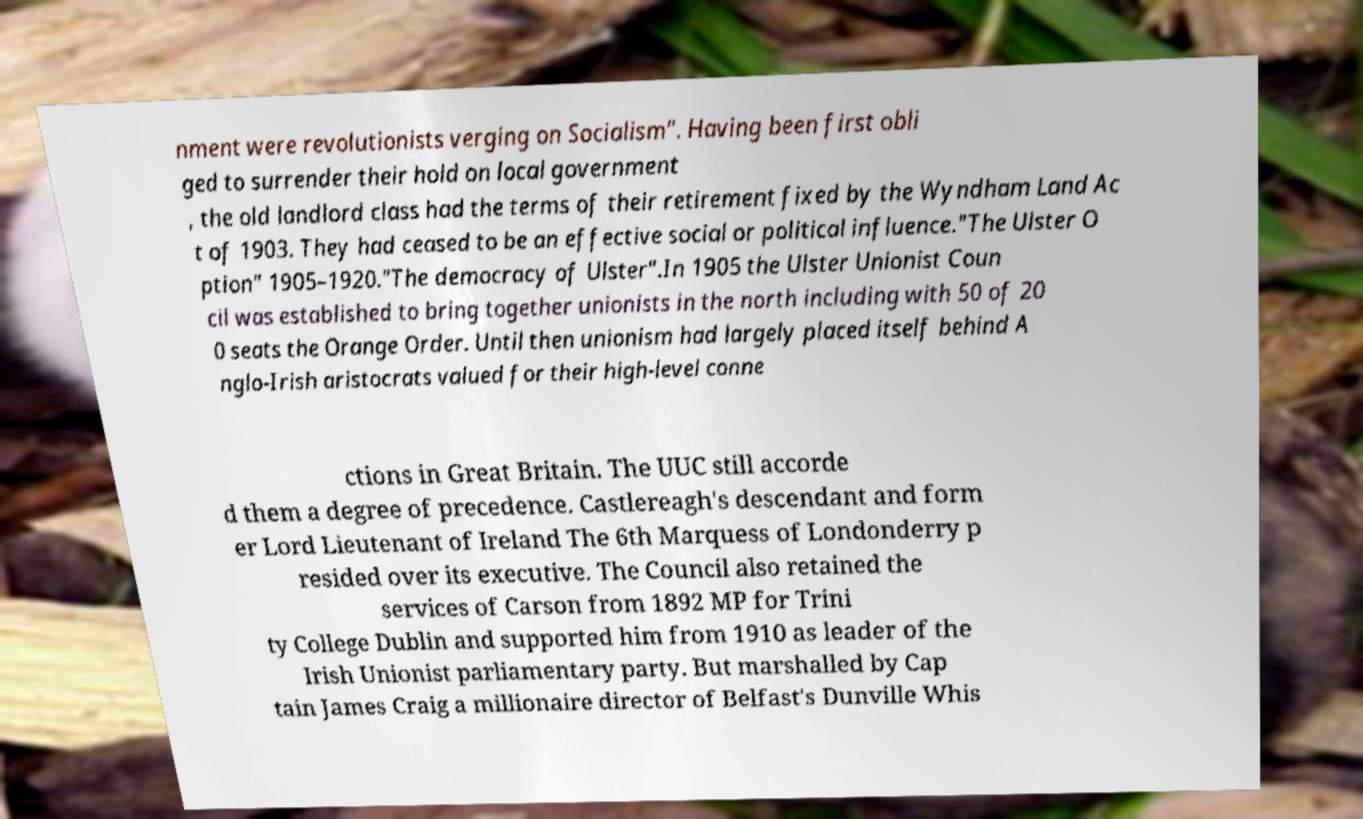Can you accurately transcribe the text from the provided image for me? nment were revolutionists verging on Socialism". Having been first obli ged to surrender their hold on local government , the old landlord class had the terms of their retirement fixed by the Wyndham Land Ac t of 1903. They had ceased to be an effective social or political influence."The Ulster O ption" 1905–1920."The democracy of Ulster".In 1905 the Ulster Unionist Coun cil was established to bring together unionists in the north including with 50 of 20 0 seats the Orange Order. Until then unionism had largely placed itself behind A nglo-Irish aristocrats valued for their high-level conne ctions in Great Britain. The UUC still accorde d them a degree of precedence. Castlereagh's descendant and form er Lord Lieutenant of Ireland The 6th Marquess of Londonderry p resided over its executive. The Council also retained the services of Carson from 1892 MP for Trini ty College Dublin and supported him from 1910 as leader of the Irish Unionist parliamentary party. But marshalled by Cap tain James Craig a millionaire director of Belfast's Dunville Whis 